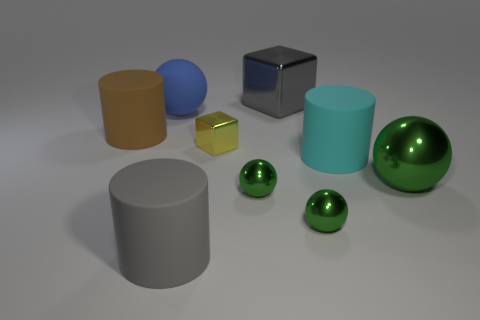How many green spheres must be subtracted to get 1 green spheres? 2 Subtract all purple cylinders. How many green balls are left? 3 Subtract all cylinders. How many objects are left? 6 Add 8 small green things. How many small green things are left? 10 Add 1 big cylinders. How many big cylinders exist? 4 Subtract 0 purple cylinders. How many objects are left? 9 Subtract all green balls. Subtract all cubes. How many objects are left? 4 